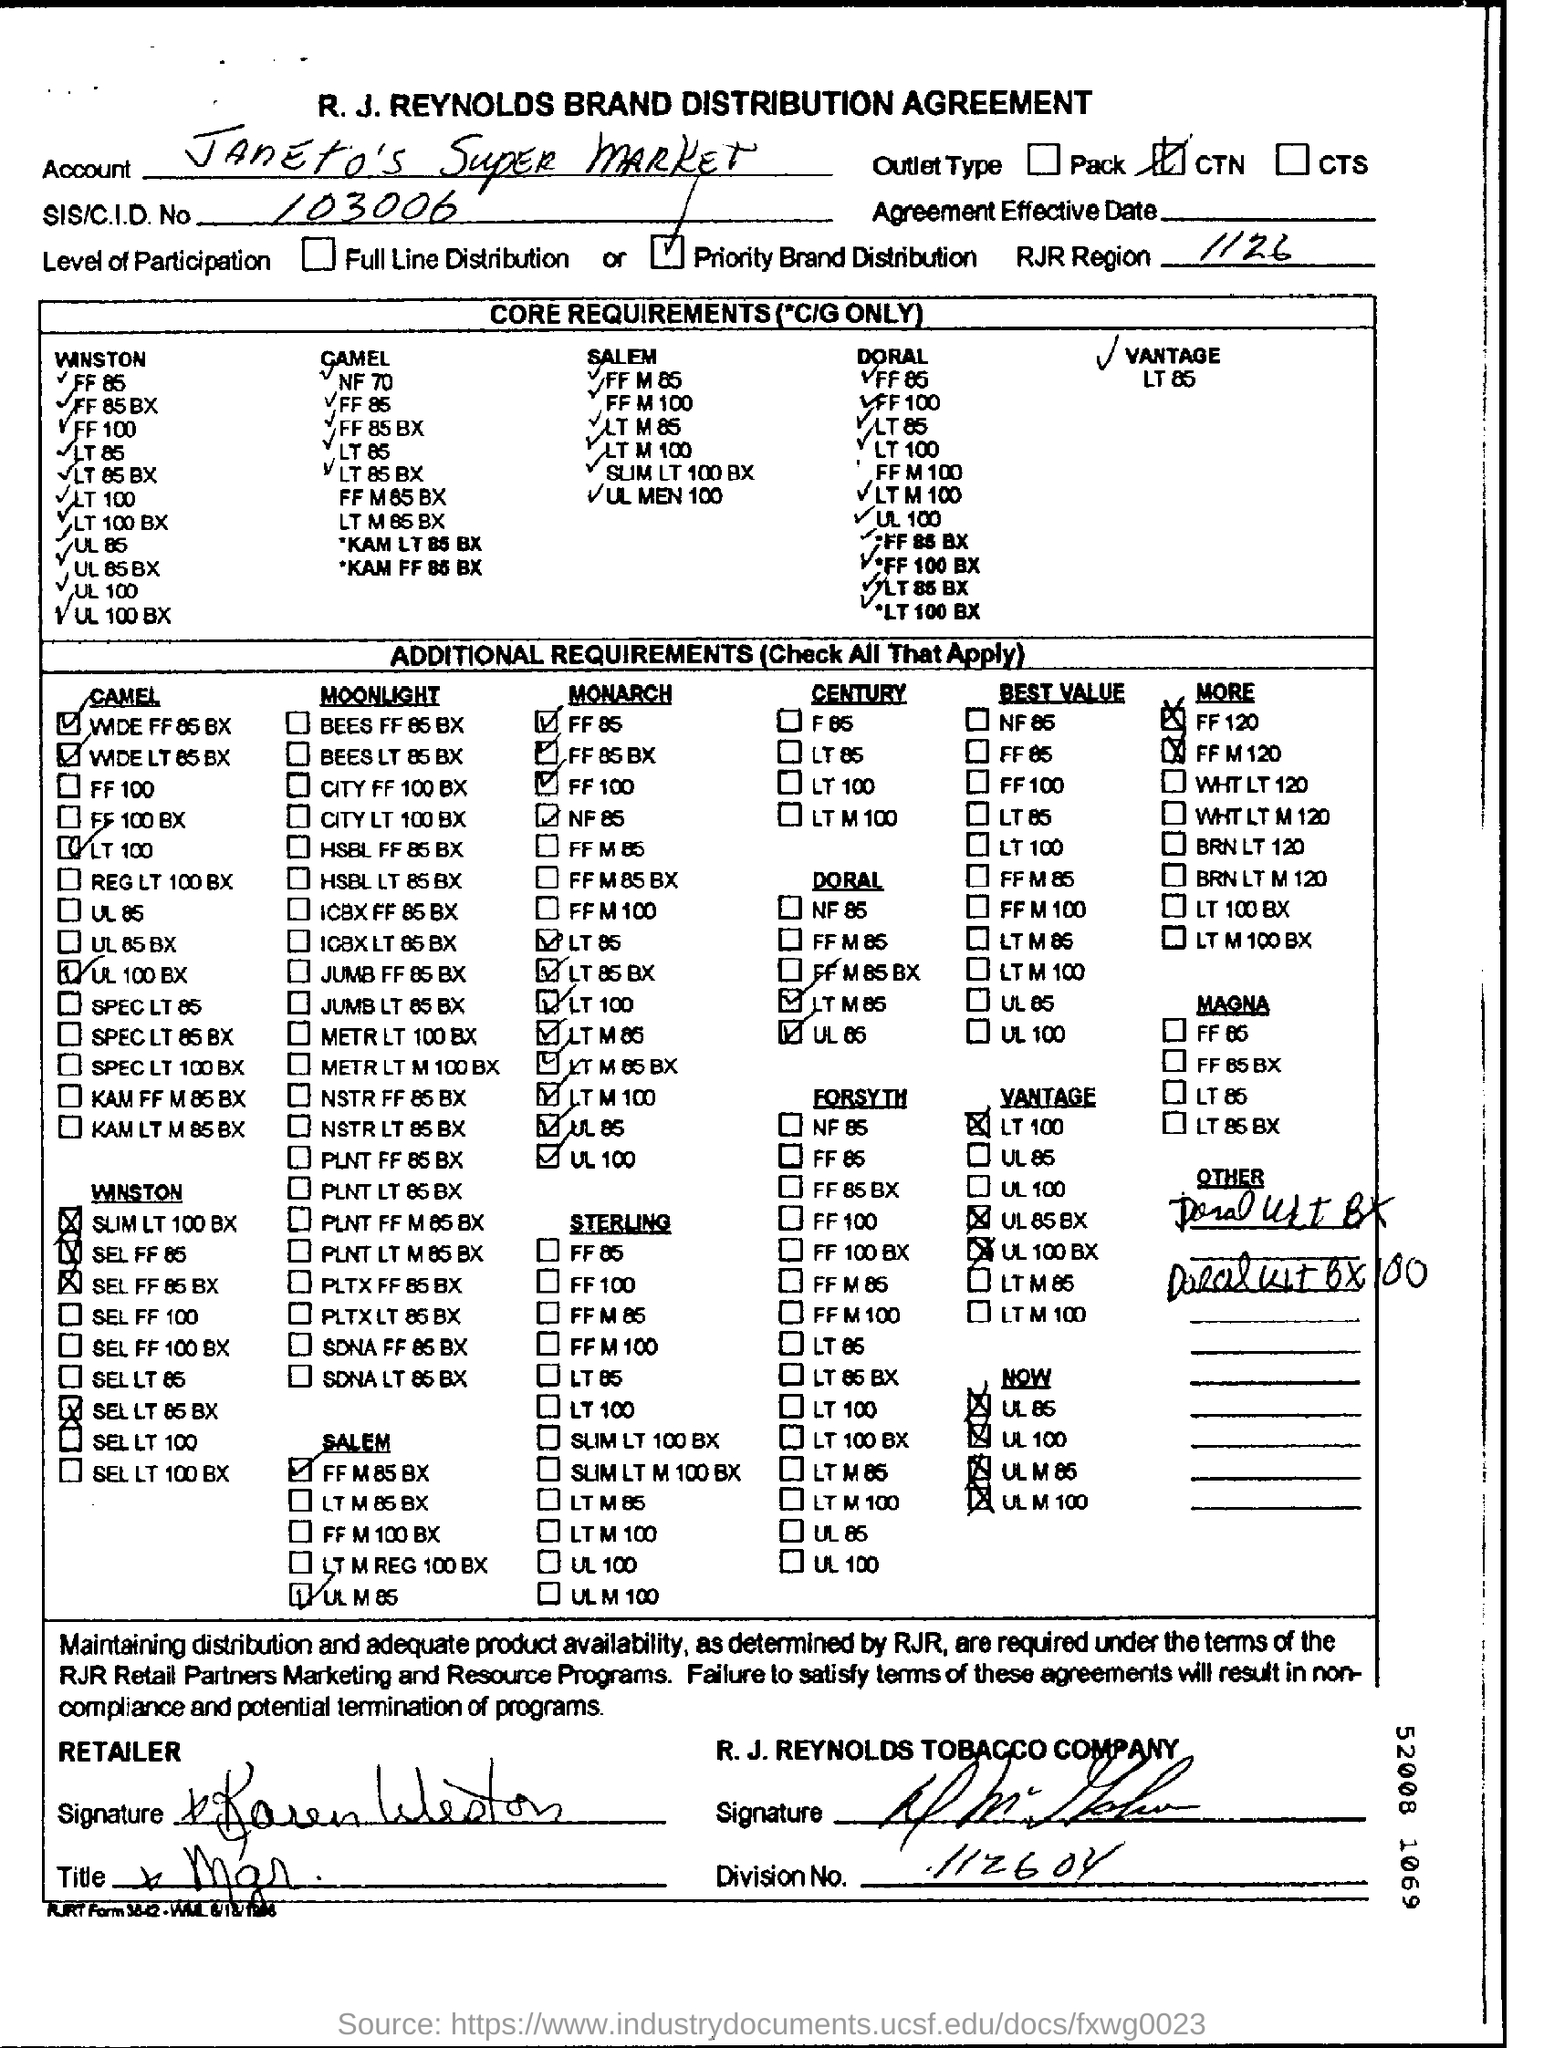What is written in the Letter Head ?
Your answer should be very brief. R. J. REYNOLDS BRAND DISTRIBUTION AGREEMENT. What is the Account Name ?
Your answer should be compact. Janeto's Super Market. What is the RJR Region Number ?
Make the answer very short. 1126. What is the SIS Number ?
Provide a short and direct response. 103006. What is the Company Name ?
Provide a succinct answer. RJR. 